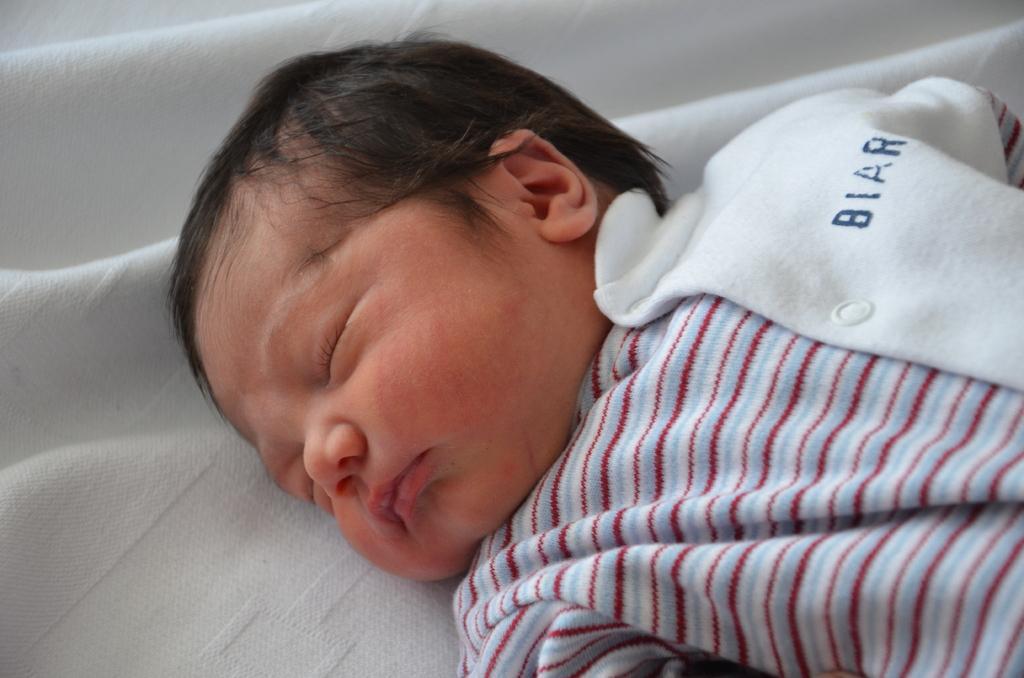Describe this image in one or two sentences. In this image we can see a baby wearing dress is laying on a cloth. 